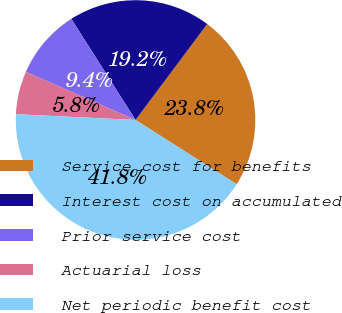Convert chart to OTSL. <chart><loc_0><loc_0><loc_500><loc_500><pie_chart><fcel>Service cost for benefits<fcel>Interest cost on accumulated<fcel>Prior service cost<fcel>Actuarial loss<fcel>Net periodic benefit cost<nl><fcel>23.8%<fcel>19.22%<fcel>9.41%<fcel>5.82%<fcel>41.76%<nl></chart> 